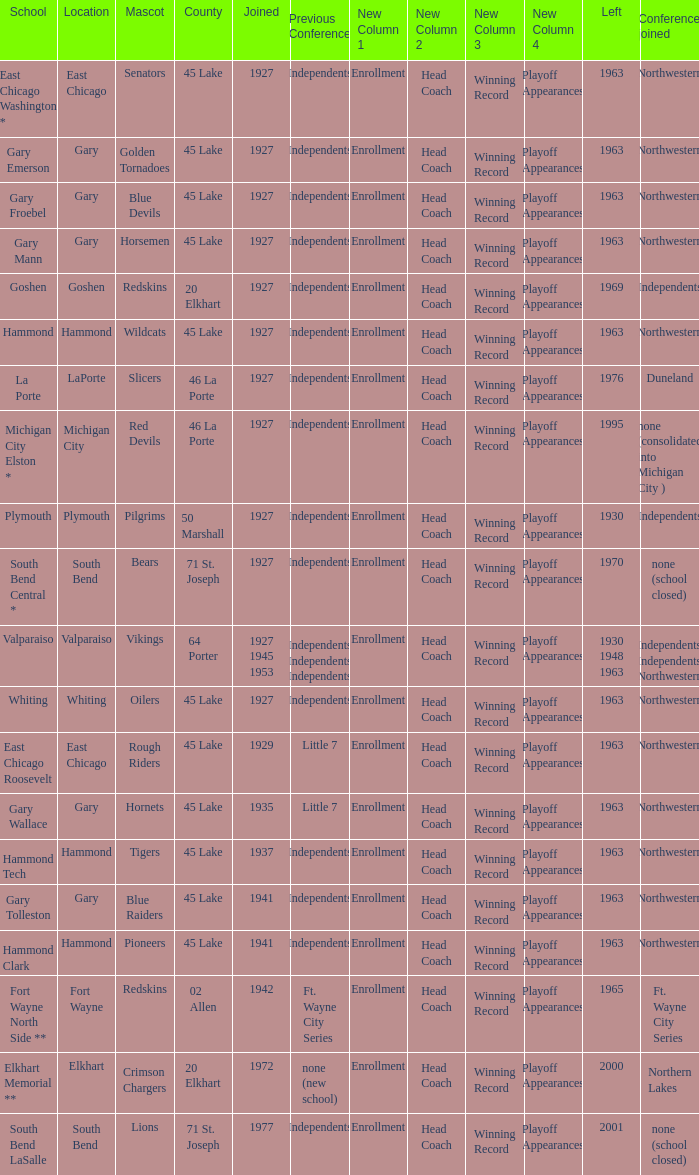When doeas Mascot of blue devils in Gary Froebel School? 1927.0. 